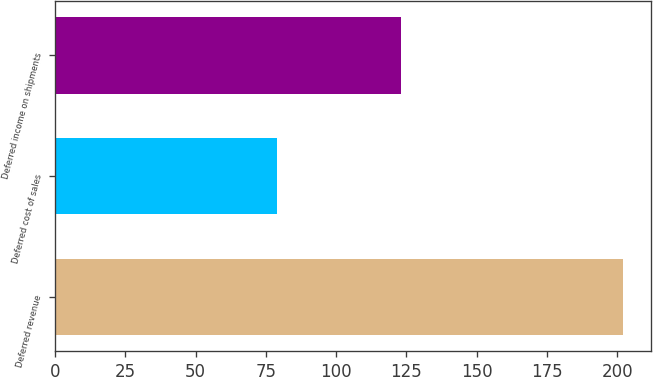<chart> <loc_0><loc_0><loc_500><loc_500><bar_chart><fcel>Deferred revenue<fcel>Deferred cost of sales<fcel>Deferred income on shipments<nl><fcel>202<fcel>79<fcel>123<nl></chart> 